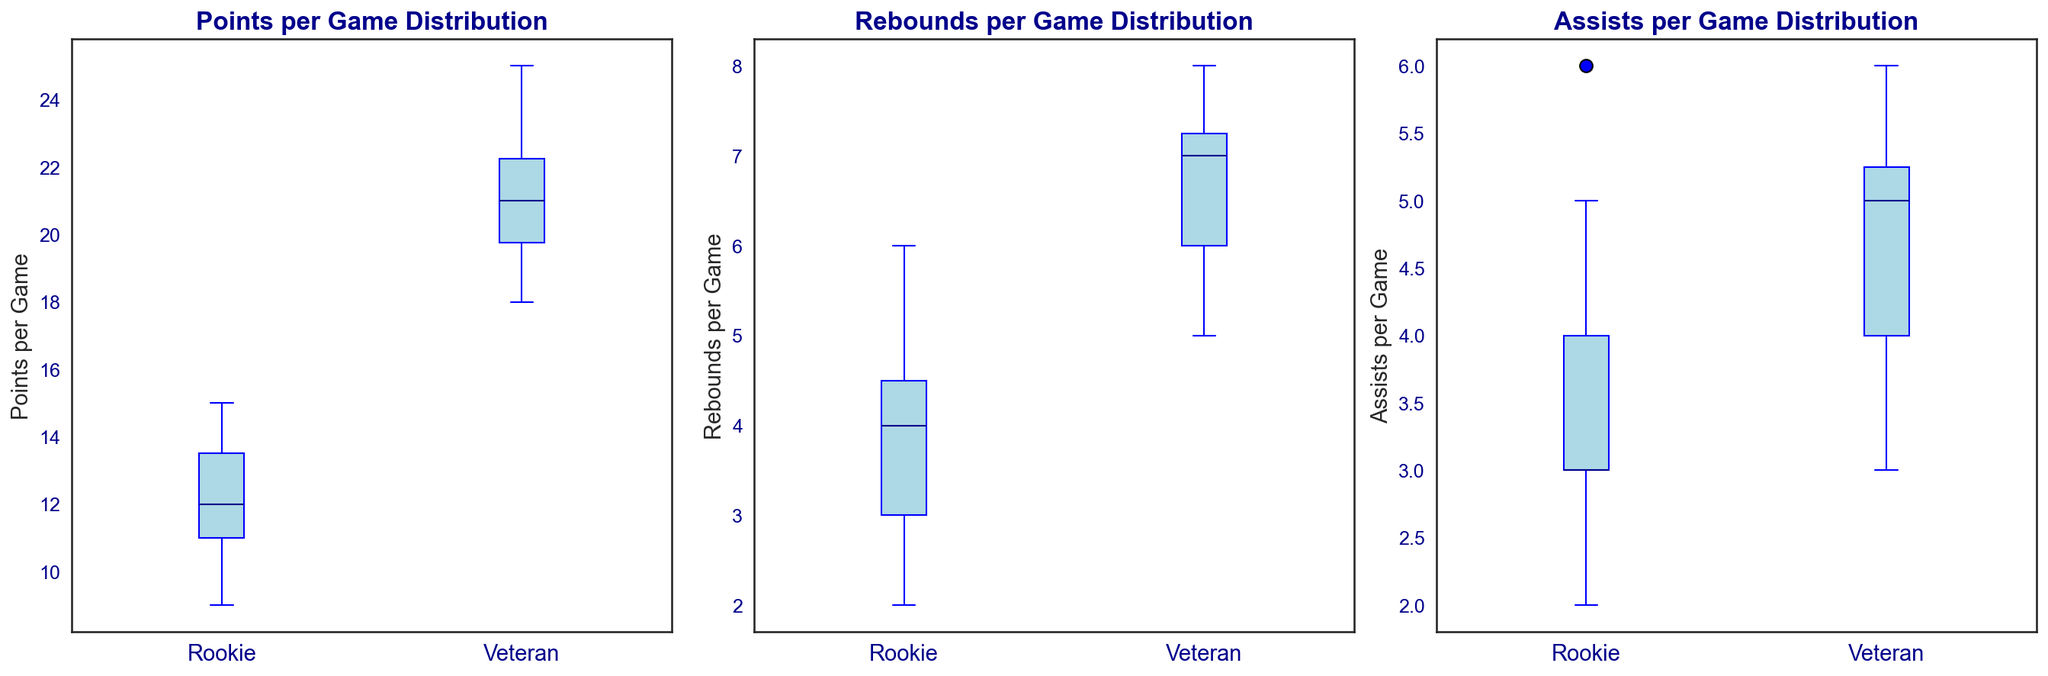Which player type has a higher median points per game? Looking at the Points per Game Distribution box plot, observe the median line within each box. The median line for veterans is higher than for rookies.
Answer: Veterans What is the interquartile range (IQR) for rebounds per game for rookies? The IQR is the difference between the third quartile (75th percentile) and the first quartile (25th percentile). For rookies, estimate these values from the box plot for Rebounds per Game Distribution. The third quartile is around 5, and the first quartile is around 3. The IQR is 5 - 3 = 2.
Answer: 2 Which player type shows more variability in assists per game? Variability can be deduced from the length of the box and the spread of the whiskers in the Assists per Game Distribution box plot. Rookies have a wider box and longer whiskers, indicating more variability.
Answer: Rookies Compare the median points per game of rookies to the median assists per game of veterans. Locate the median line in the Points per Game Distribution box plot for rookies and the median line in the Assists per Game Distribution for veterans. The median points per game for rookies is around 12.5, while the median assists per game for veterans is around 5.
Answer: Median points per game of rookies is higher than median assists per game of veterans Which player type has fewer outliers in rebounds per game? Outliers are represented by dots outside the whiskers. In the Rebounds per Game Distribution box plot, observe that there are more outliers visible for veterans compared to rookies.
Answer: Rookies What is the median rebounds per game for veterans? Find the median line inside the veteran's box in the Rebounds per Game Distribution plot. It intersects around 7.
Answer: 7 Which player type has a higher maximum value for points per game? The maximum value is depicted by the topmost whisker in the Points per Game Distribution box plot. For veterans, this whisker extends higher than for rookies.
Answer: Veterans Compare the spread of points per game between rookies and veterans. The spread can be judged by the length of the whiskers and the height of the box. Veterans show a larger spread as their whiskers extend from approximately 18 to 25, while rookies extend roughly from 9 to 15.
Answer: Veterans have a larger spread In which category do veterans perform more consistently compared to rookies? Consistency is indicated by a smaller box and shorter whiskers. Veterans have tighter boxes and shorter whiskers in the Assists per Game Distribution, indicating more consistent performance there.
Answer: Assists per Game 